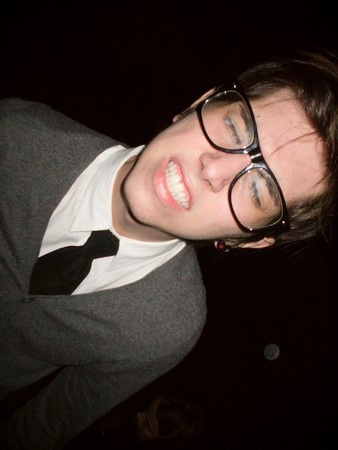Describe the objects in this image and their specific colors. I can see people in black, lightpink, gray, and lightgray tones and tie in black, lightgray, gray, and darkgray tones in this image. 